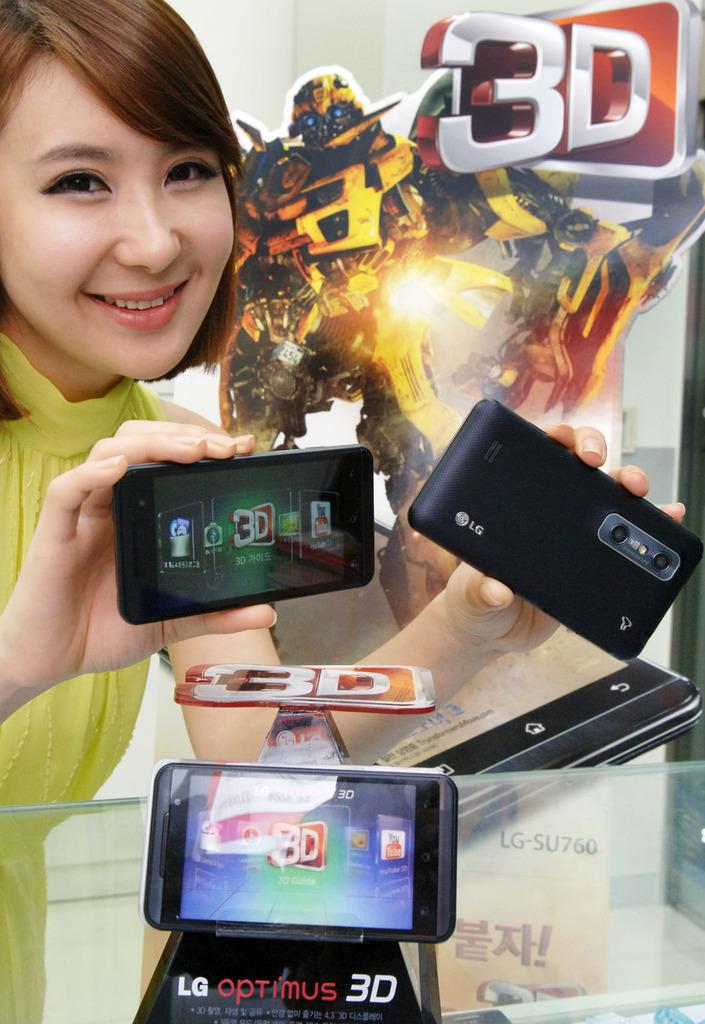What brand is the phone?
Offer a very short reply. Lg. 